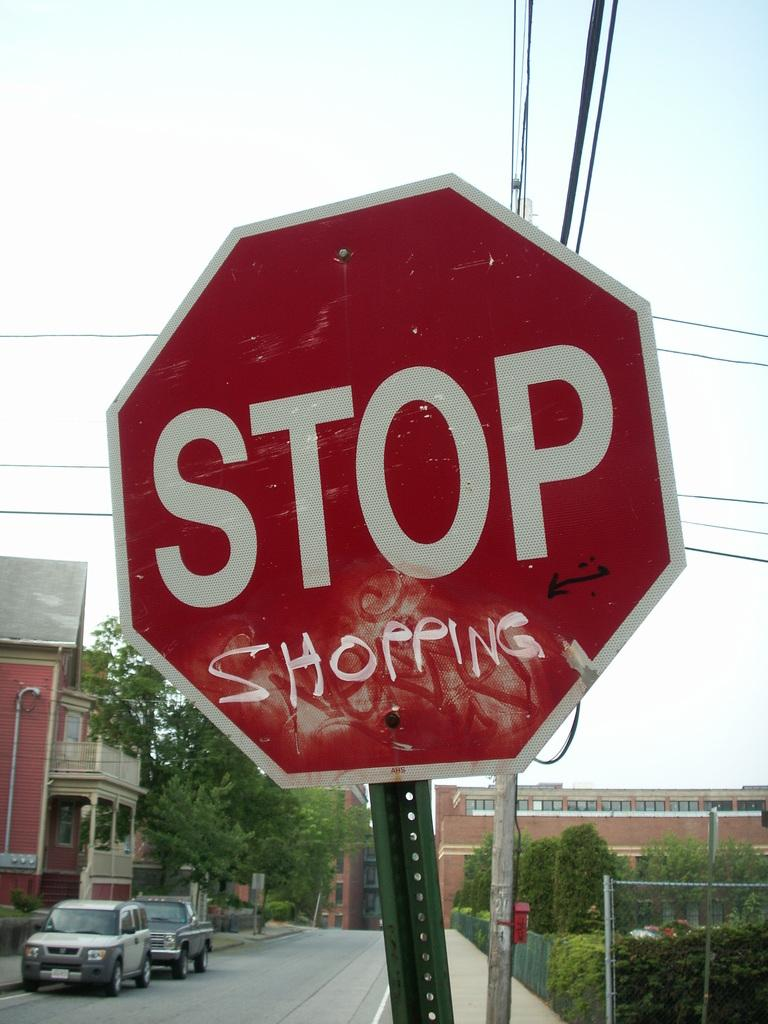<image>
Describe the image concisely. A crooked stop sign that has graffiti etched under stop that says SHOPPING. 